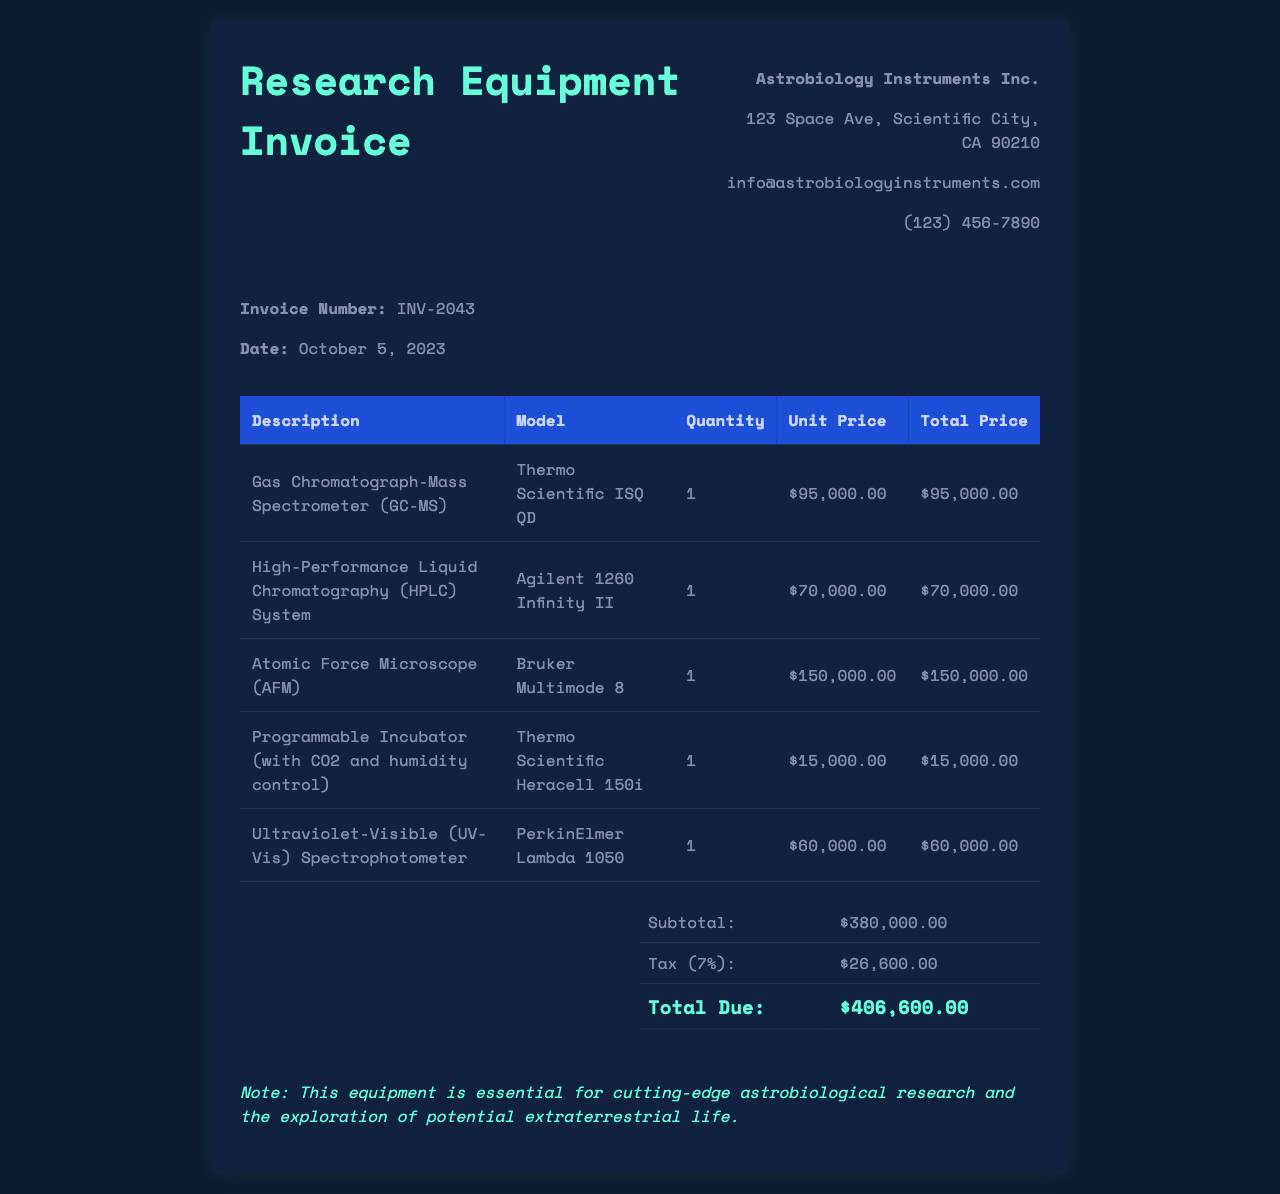What is the invoice number? The invoice number is stated in the document under invoice details.
Answer: INV-2043 When was the invoice issued? The date of the invoice can be found in the invoice details section.
Answer: October 5, 2023 What is the total due amount? The total due amount is at the end of the total section.
Answer: $406,600.00 How many items are listed in the invoice? Count the number of product rows in the table, which represent the items.
Answer: 5 What is the model of the Gas Chromatograph-Mass Spectrometer? The model is mentioned in the table next to the description of the item.
Answer: Thermo Scientific ISQ QD What is the subtotal before tax? The subtotal is listed right above the tax amount in the total section.
Answer: $380,000.00 Which item has the highest cost? Identify the item with the highest unit price in the table.
Answer: Atomic Force Microscope (AFM) What is the tax rate applied to the invoice? The tax rate is presented alongside the tax total in the total section.
Answer: 7% What does the note at the bottom of the invoice imply about the equipment? The note emphasizes the importance of the equipment for research purposes, found at the bottom of the invoice.
Answer: Essential for cutting-edge astrobiological research 